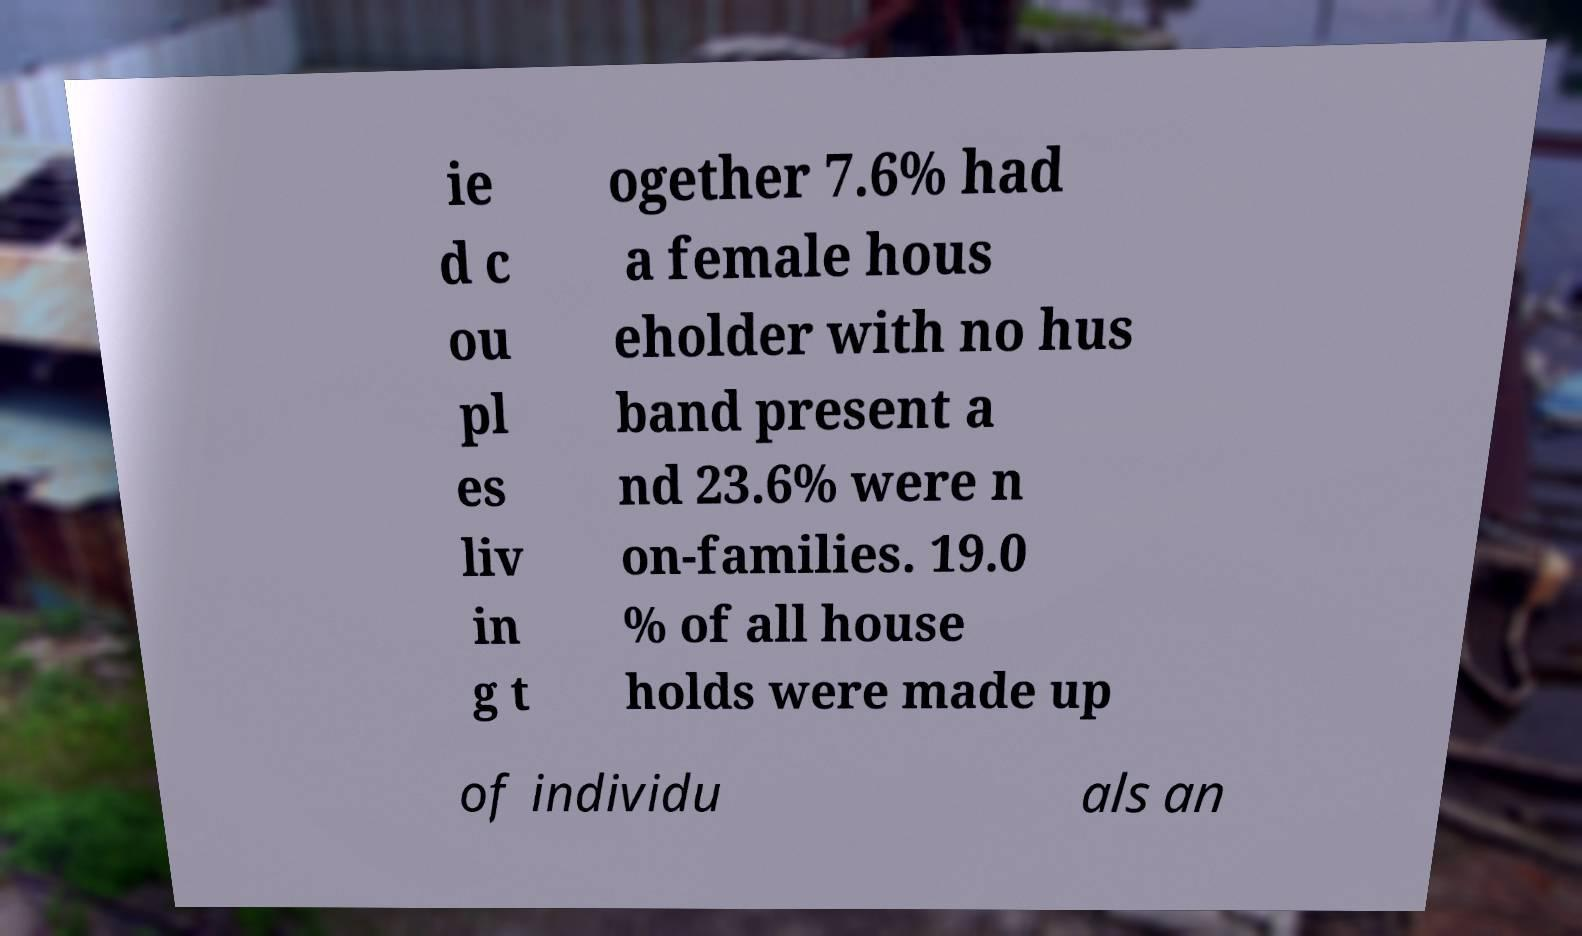Could you extract and type out the text from this image? ie d c ou pl es liv in g t ogether 7.6% had a female hous eholder with no hus band present a nd 23.6% were n on-families. 19.0 % of all house holds were made up of individu als an 